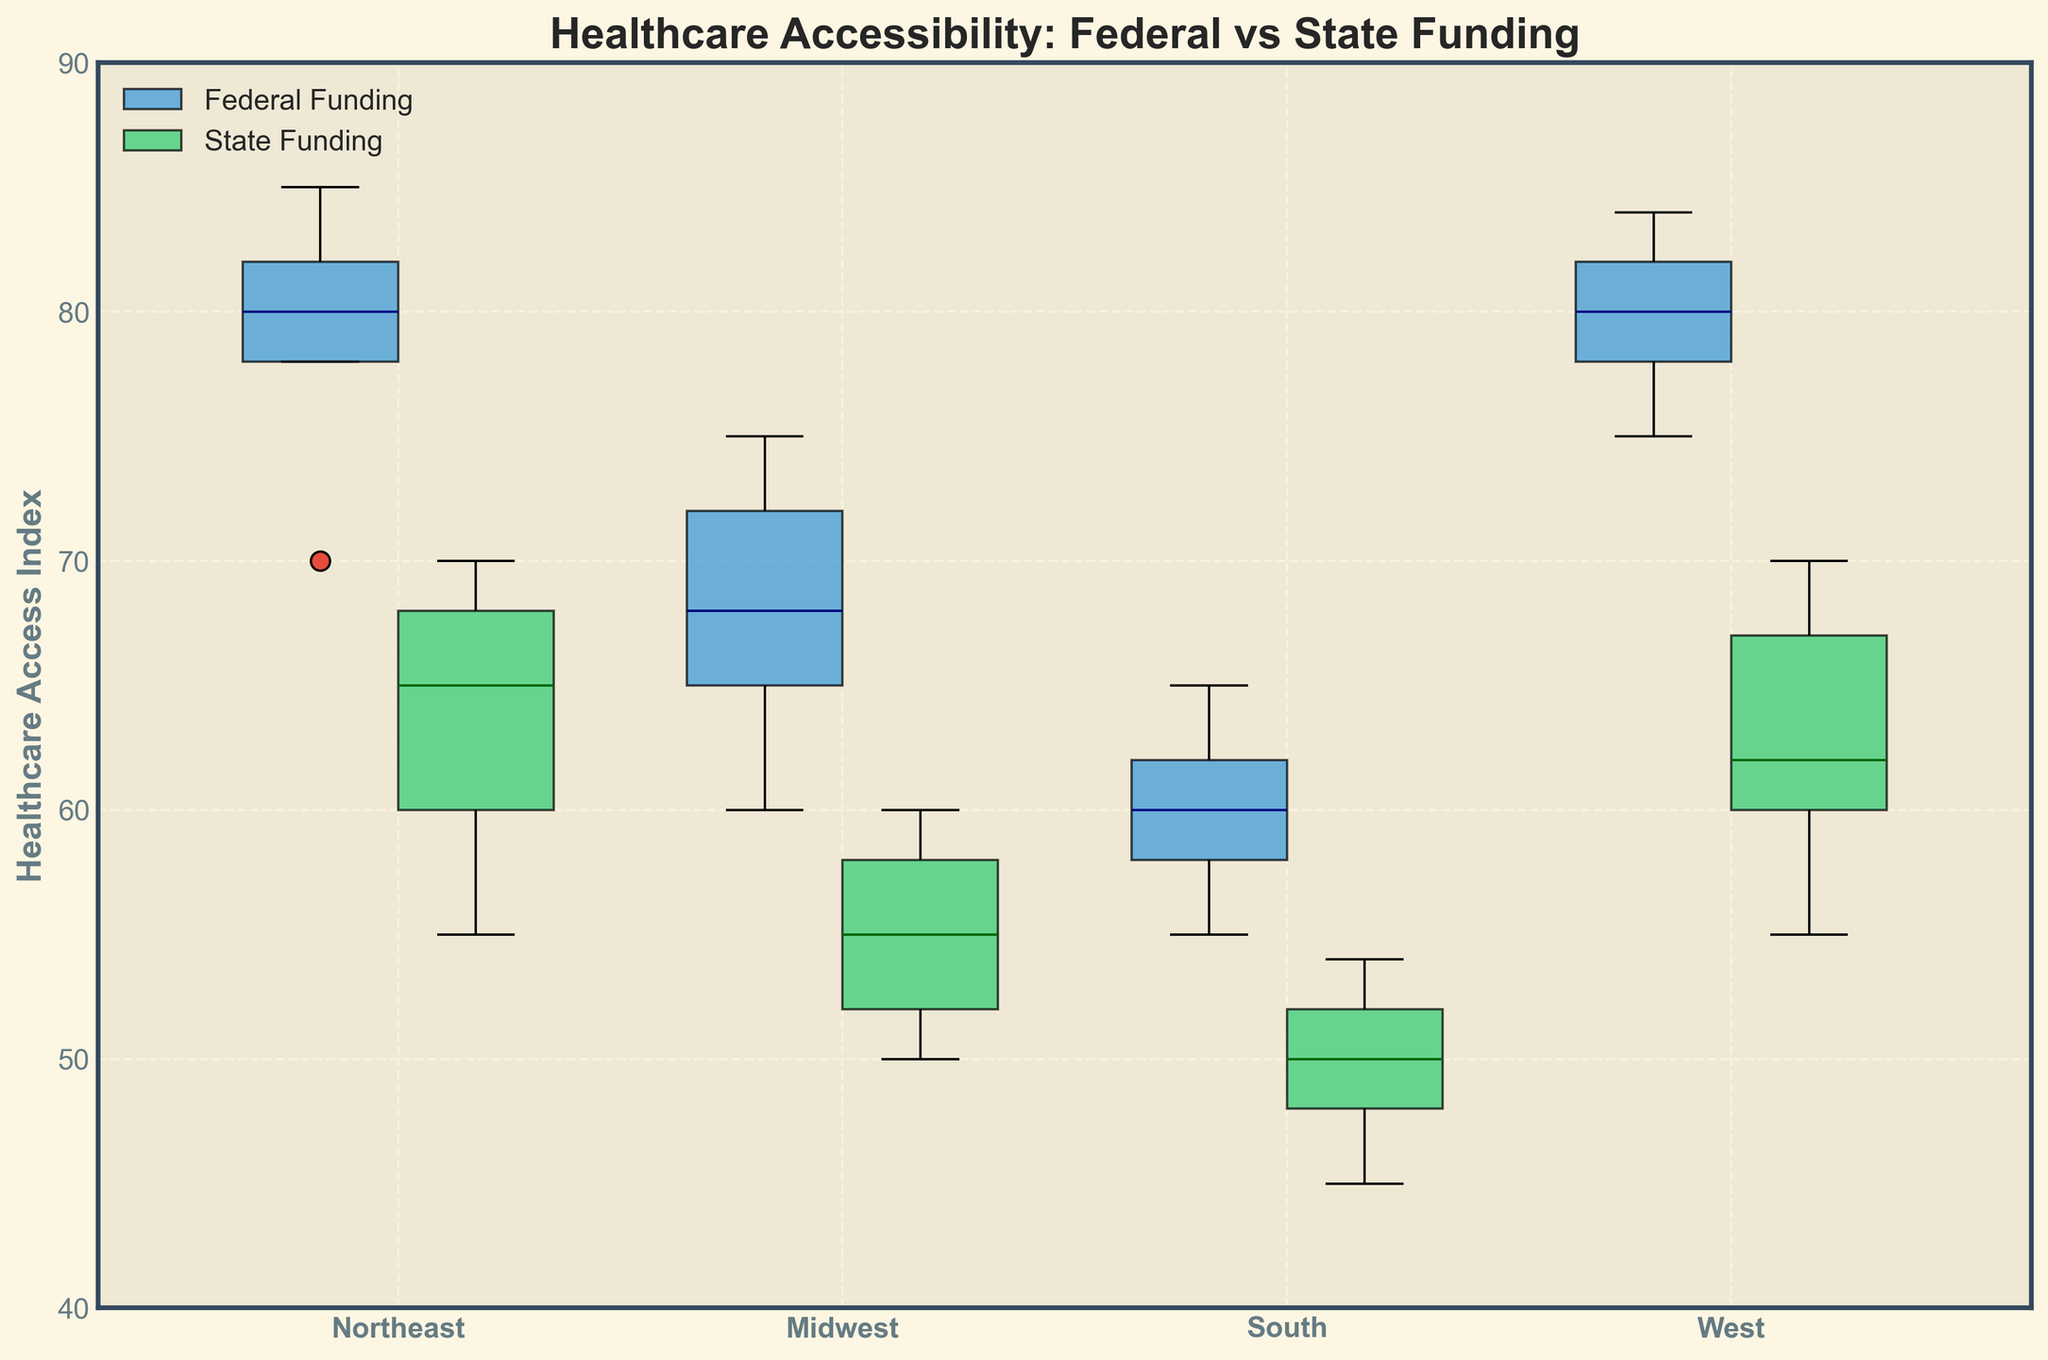What is the title of the plot? The title of the plot is displayed prominently at the top center of the figure.
Answer: Healthcare Accessibility: Federal vs State Funding Which region has the highest median Healthcare Access Index for Federal Funding? To find the highest median Healthcare Access Index for Federal Funding, we compare the central line (median) of the blue boxes. The West region shows the highest central line.
Answer: West What is the median Healthcare Access Index for State Funding in the Midwest region? The median value is represented by the central line within the green box for the Midwest region positioned at the second set of box plots from the left.
Answer: 55 Compare the spread of Healthcare Access Index scores in the Northeast region for Federal and State Funding. Which has a greater range? The range is identified by the distance between the bottom and top of the box (Interquartile Range, or IQR). For the Northeast, the Federal funding (blue box) has a wider IQR compared to State funding (green box).
Answer: Federal Does the South region show a higher median Healthcare Access Index for Federal or State Funding? Examine the central lines in the blue box (Federal) and green box (State) for the South region. The blue box has a higher central line than the green one.
Answer: Federal How does the median Healthcare Access Index for Federal Funding in the South compare to the State Funding? To compare, we check the median line in each box plot. The median of Federal funding (blue box) is higher than the State funding (green box) in the South region.
Answer: Higher Are there any outliers in the Healthcare Access Index for State Funding in the Midwest region? Outliers are represented by distinct marker shapes outside the main box and whiskers. In the Midwest region, for State funding, no marker shapes are present outside the green box and whiskers, indicating no outliers.
Answer: No Which region shows the widest spread in Healthcare Access Index for State Funding? The widest spread (Interquartile Range) can be identified by comparing the green box lengths across regions. The West region has the widest green box indicating the largest spread for State funding.
Answer: West What is the minimum Healthcare Access Index for Federal Funding in the Northeast region? The minimum value is the lower whisker of the blue box in the Northeast region.
Answer: 70 Is the median Healthcare Access Index higher for Federal or State Funding in the West region? The central line (median) of the blue box (Federal) and green box (State) in the West region shows Federal funding has a higher median.
Answer: Federal 